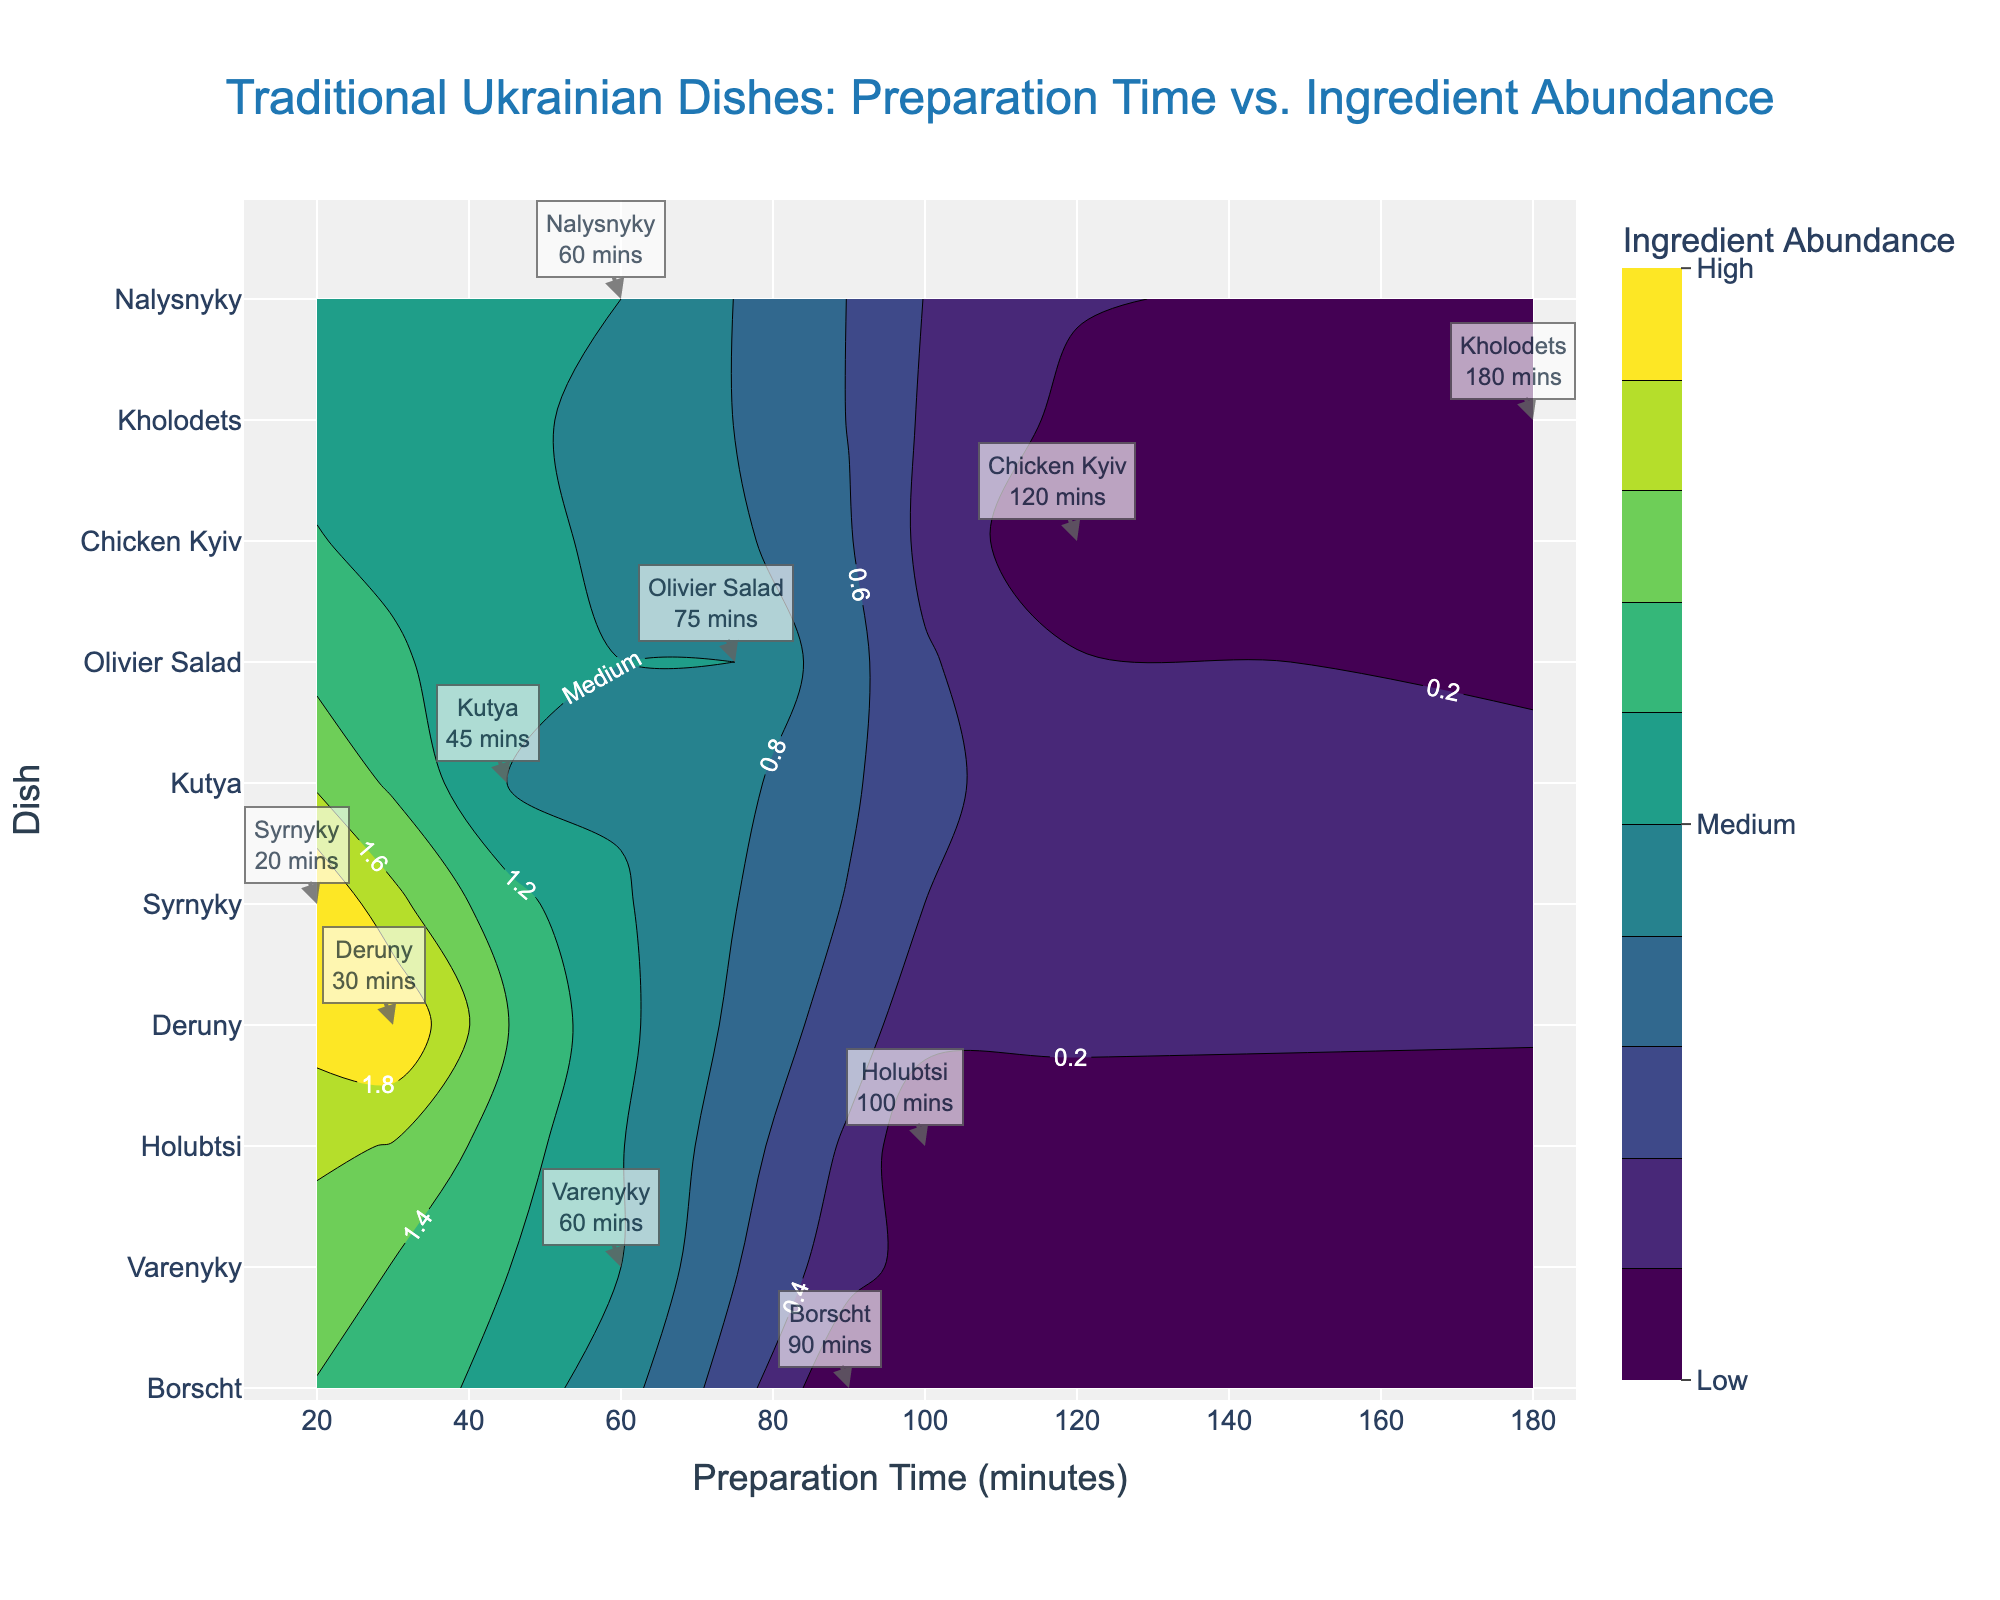What's the title of the plot? The title is located at the top of the plot. It reads "Traditional Ukrainian Dishes: Preparation Time vs. Ingredient Abundance".
Answer: Traditional Ukrainian Dishes: Preparation Time vs. Ingredient Abundance What does the X-axis represent? The labels along the X-axis indicate it represents "Preparation Time (minutes)".
Answer: Preparation Time (minutes) Which dish has the highest preparation time? The dish with the highest preparation time is found by identifying the maximum value on the X-axis and checking the corresponding dish label. The highest value is 180 minutes.
Answer: Kholodets How many dishes fall into the "Low" ingredient abundance category? Check the colorbar for the color representing 'Low' and count the number of dishes in that range. There are 4 dishes in this category.
Answer: 4 Which dish with a "Medium" ingredient abundance has the shortest preparation time? By identifying the dishes under "Medium" ingredient abundance, compare their preparation times. The dish with the shortest time is Syrnyky at 20 minutes.
Answer: Syrnyky What is the average preparation time for dishes in the "High" ingredient abundance category? Identify the preparation times for dishes under "High" ingredient abundance (Deruny and Syrnyky). Calculate the average: (30 + 20) / 2 = 25 minutes.
Answer: 25 minutes Compare the preparation times of Borscht and Chicken Kyiv. Which one takes longer? Look at the X-axis values for Borscht (90 minutes) and Chicken Kyiv (120 minutes). Chicken Kyiv takes longer.
Answer: Chicken Kyiv How many dishes have a preparation time greater than 60 minutes? Count the number of dishes whose preparation time exceeds 60 minutes from the X-axis labels. There are 6 dishes.
Answer: 6 Which dishes have a "Medium" ingredient abundance and a preparation time of 60 minutes? Locate the dishes with 60 minutes preparation time and check the ingredient abundance. The dishes are Varenyky and Nalysnyky.
Answer: Varenyky, Nalysnyky 